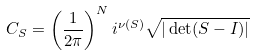<formula> <loc_0><loc_0><loc_500><loc_500>C _ { S } = \left ( \frac { 1 } { 2 \pi } \right ) ^ { N } i ^ { \nu ( S ) } \sqrt { | \det ( S - I ) | }</formula> 